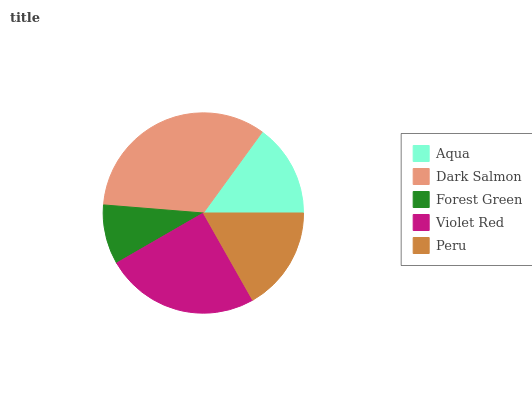Is Forest Green the minimum?
Answer yes or no. Yes. Is Dark Salmon the maximum?
Answer yes or no. Yes. Is Dark Salmon the minimum?
Answer yes or no. No. Is Forest Green the maximum?
Answer yes or no. No. Is Dark Salmon greater than Forest Green?
Answer yes or no. Yes. Is Forest Green less than Dark Salmon?
Answer yes or no. Yes. Is Forest Green greater than Dark Salmon?
Answer yes or no. No. Is Dark Salmon less than Forest Green?
Answer yes or no. No. Is Peru the high median?
Answer yes or no. Yes. Is Peru the low median?
Answer yes or no. Yes. Is Forest Green the high median?
Answer yes or no. No. Is Aqua the low median?
Answer yes or no. No. 